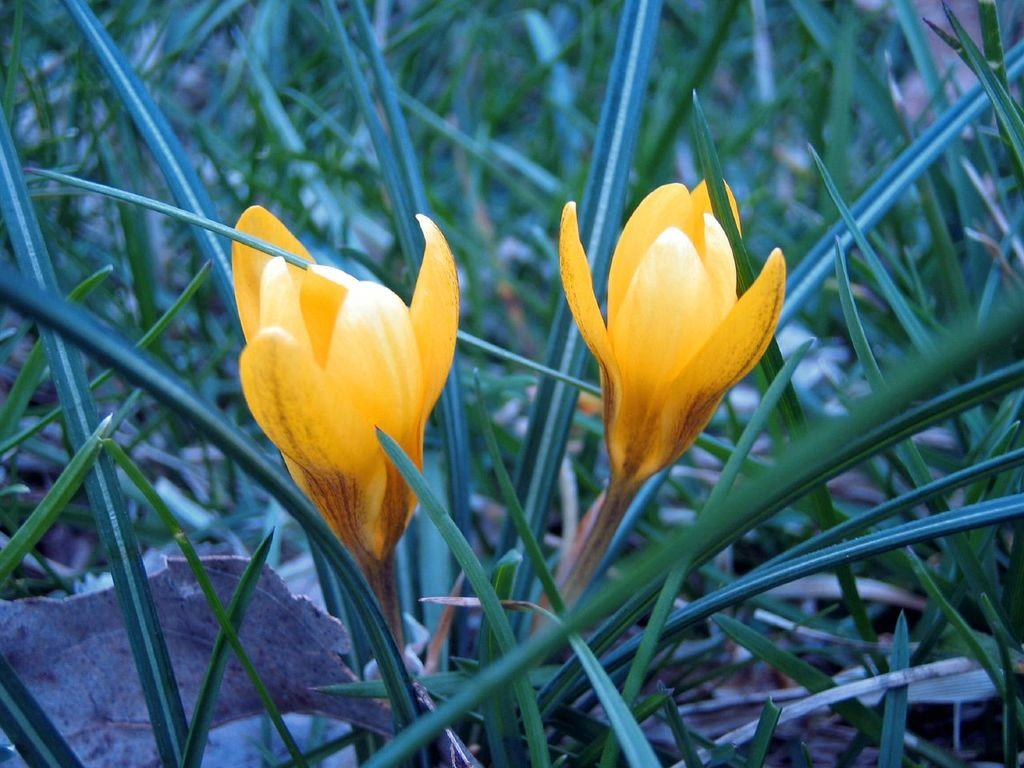What type of living organisms can be seen in the image? Plants can be seen in the image. How many flowers are present in the image? There are two flowers in the image. What color are the flowers? The flowers are yellow in color. What type of tent can be seen in the image? There is no tent present in the image. What is the purpose of the flowers in the image? The flowers are not shown to have a specific purpose in the image; they are simply present as part of the plant. 